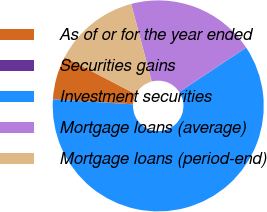Convert chart to OTSL. <chart><loc_0><loc_0><loc_500><loc_500><pie_chart><fcel>As of or for the year ended<fcel>Securities gains<fcel>Investment securities<fcel>Mortgage loans (average)<fcel>Mortgage loans (period-end)<nl><fcel>6.63%<fcel>0.04%<fcel>60.29%<fcel>19.81%<fcel>13.22%<nl></chart> 